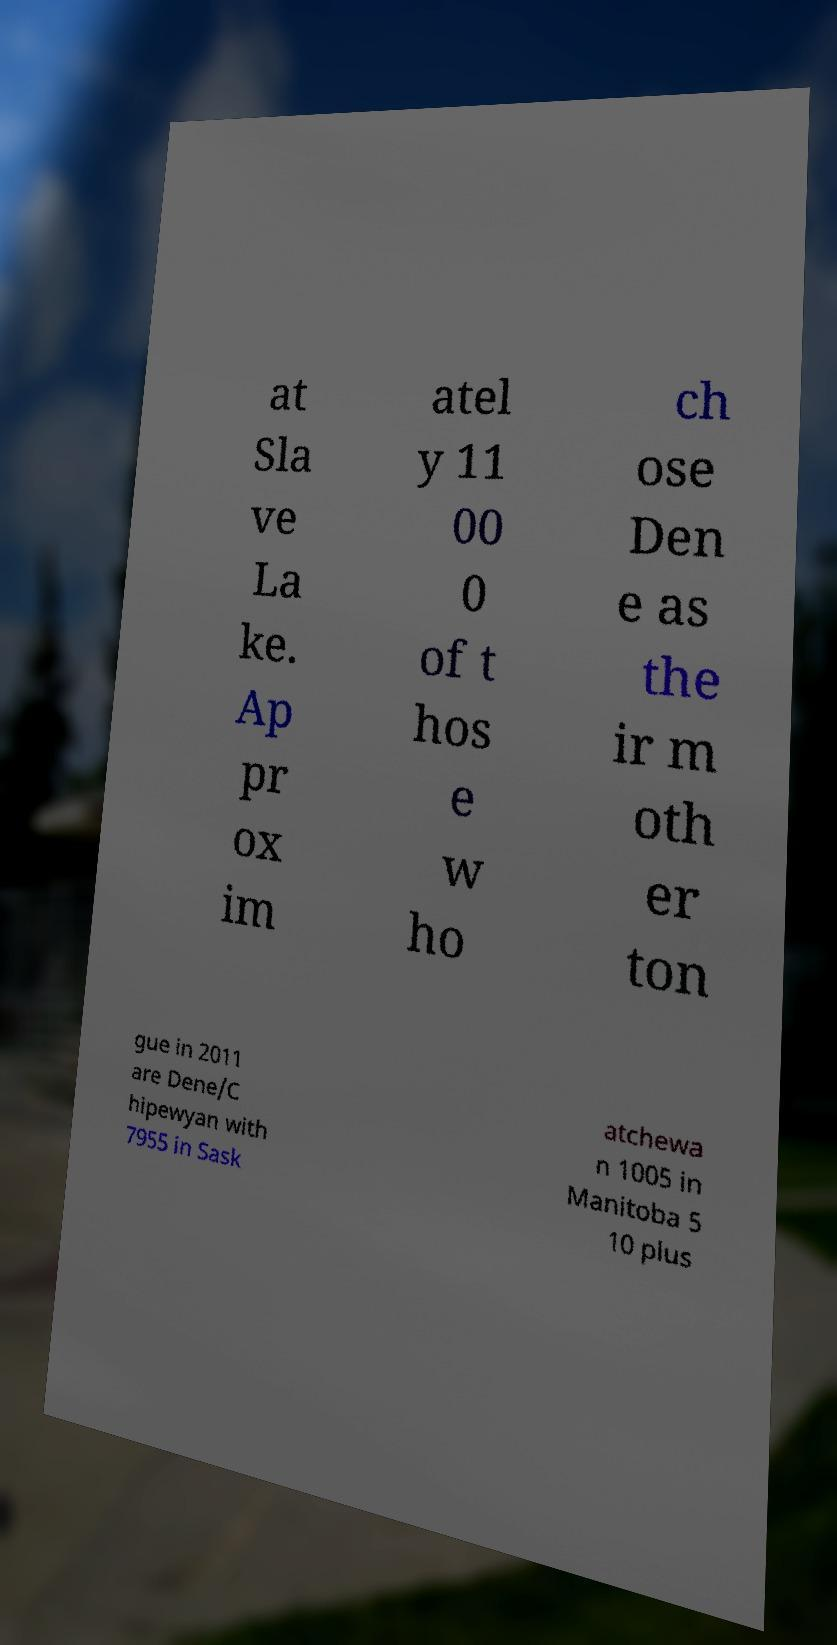Please read and relay the text visible in this image. What does it say? at Sla ve La ke. Ap pr ox im atel y 11 00 0 of t hos e w ho ch ose Den e as the ir m oth er ton gue in 2011 are Dene/C hipewyan with 7955 in Sask atchewa n 1005 in Manitoba 5 10 plus 